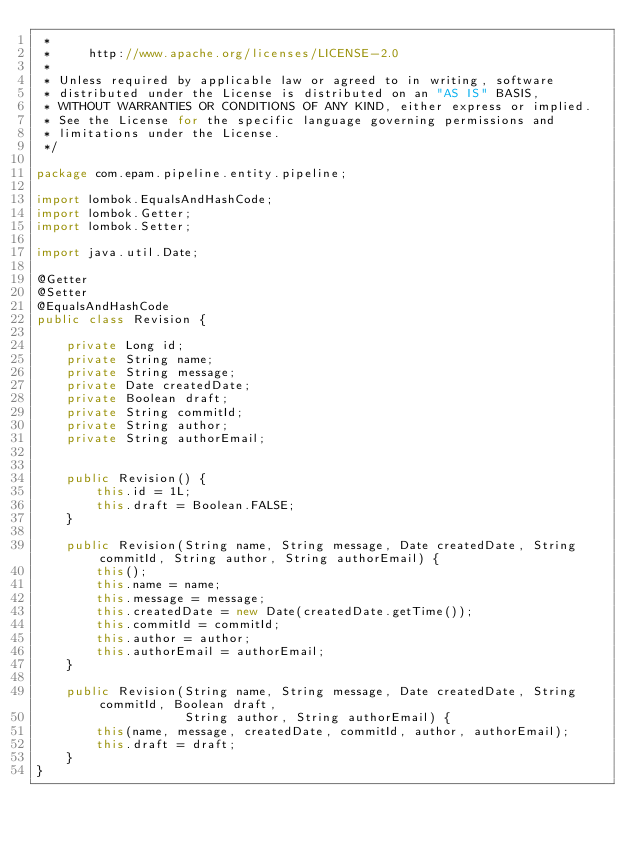Convert code to text. <code><loc_0><loc_0><loc_500><loc_500><_Java_> *
 *     http://www.apache.org/licenses/LICENSE-2.0
 *
 * Unless required by applicable law or agreed to in writing, software
 * distributed under the License is distributed on an "AS IS" BASIS,
 * WITHOUT WARRANTIES OR CONDITIONS OF ANY KIND, either express or implied.
 * See the License for the specific language governing permissions and
 * limitations under the License.
 */

package com.epam.pipeline.entity.pipeline;

import lombok.EqualsAndHashCode;
import lombok.Getter;
import lombok.Setter;

import java.util.Date;

@Getter
@Setter
@EqualsAndHashCode
public class Revision {

    private Long id;
    private String name;
    private String message;
    private Date createdDate;
    private Boolean draft;
    private String commitId;
    private String author;
    private String authorEmail;


    public Revision() {
        this.id = 1L;
        this.draft = Boolean.FALSE;
    }

    public Revision(String name, String message, Date createdDate, String commitId, String author, String authorEmail) {
        this();
        this.name = name;
        this.message = message;
        this.createdDate = new Date(createdDate.getTime());
        this.commitId = commitId;
        this.author = author;
        this.authorEmail = authorEmail;
    }

    public Revision(String name, String message, Date createdDate, String commitId, Boolean draft,
                    String author, String authorEmail) {
        this(name, message, createdDate, commitId, author, authorEmail);
        this.draft = draft;
    }
}
</code> 